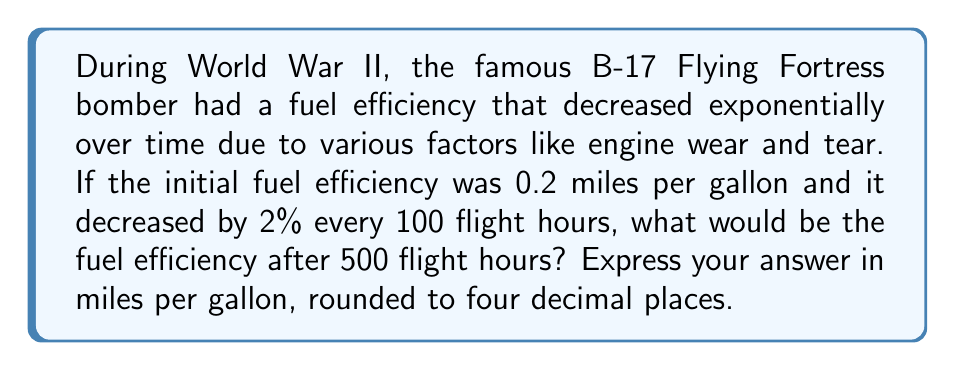Solve this math problem. To solve this problem, we'll use the exponential decay model:

$$ A = A_0 \cdot (1-r)^t $$

Where:
$A$ = Final amount
$A_0$ = Initial amount
$r$ = Decay rate per unit time
$t$ = Number of time units

Given:
$A_0 = 0.2$ miles per gallon (initial fuel efficiency)
$r = 0.02$ (2% decrease every 100 flight hours)
$t = 5$ (500 flight hours ÷ 100 flight hours per decay period)

Let's plug these values into our equation:

$$ A = 0.2 \cdot (1-0.02)^5 $$

Now, let's solve this step-by-step:

1) First, calculate $(1-0.02)^5$:
   $$(0.98)^5 = 0.9039208$$

2) Now multiply this by the initial fuel efficiency:
   $$0.2 \cdot 0.9039208 = 0.1807842$$

3) Rounding to four decimal places:
   $$0.1807842 \approx 0.1808$$

Therefore, after 500 flight hours, the fuel efficiency of the B-17 Flying Fortress would be approximately 0.1808 miles per gallon.
Answer: 0.1808 miles per gallon 